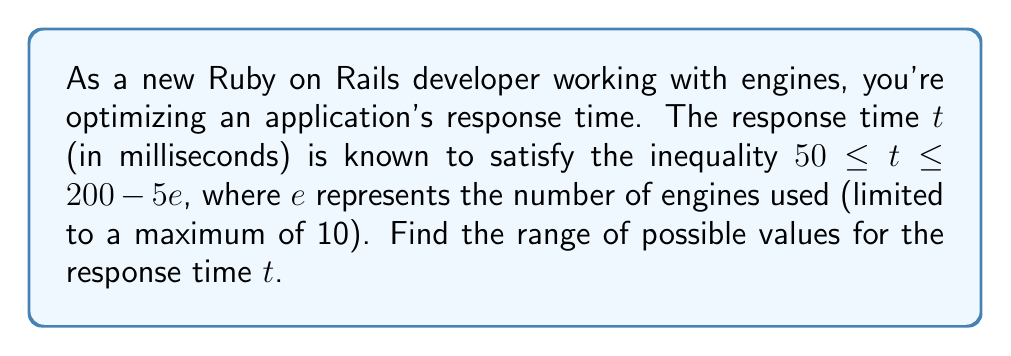Provide a solution to this math problem. Let's approach this step-by-step:

1) We're given that $50 \leq t \leq 200 - 5e$, where $e$ is the number of engines used.

2) We know that $e$ has a maximum value of 10. To find the range of $t$, we need to consider both the minimum and maximum values of $e$.

3) Minimum value of $e$:
   When $e = 0$ (no engines used), the upper bound of $t$ is maximum:
   $t \leq 200 - 5(0) = 200$

4) Maximum value of $e$:
   When $e = 10$, the upper bound of $t$ is minimum:
   $t \leq 200 - 5(10) = 150$

5) Combining these with the lower bound of 50 ms, we get:
   $50 \leq t \leq 150$

6) Therefore, the response time $t$ can be any value from 50 ms to 150 ms, inclusive.
Answer: $[50, 150]$ ms 